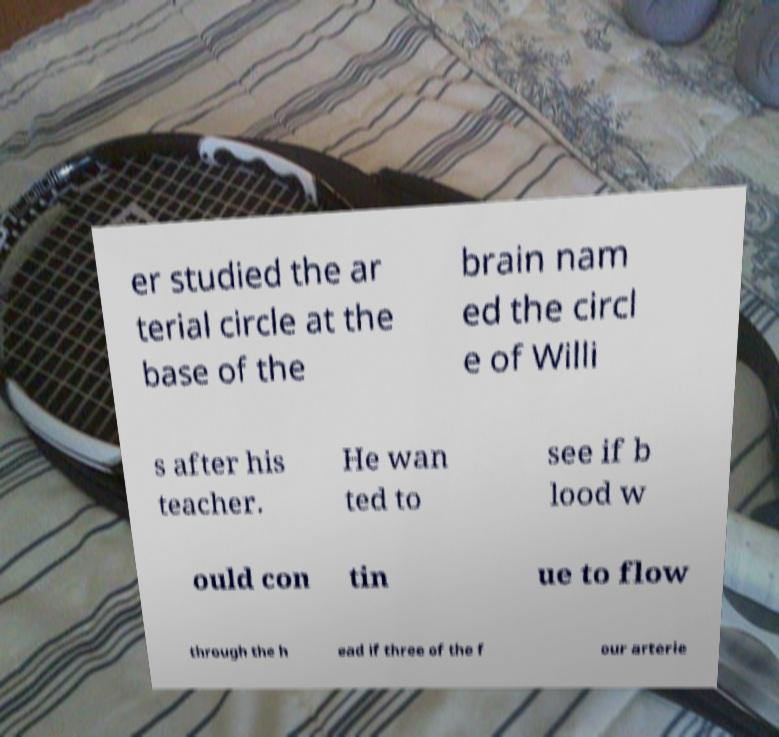There's text embedded in this image that I need extracted. Can you transcribe it verbatim? er studied the ar terial circle at the base of the brain nam ed the circl e of Willi s after his teacher. He wan ted to see if b lood w ould con tin ue to flow through the h ead if three of the f our arterie 